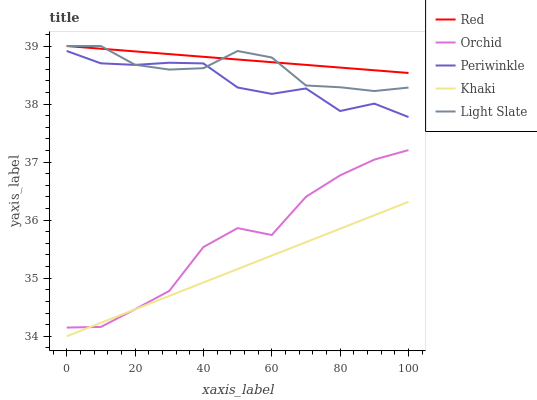Does Khaki have the minimum area under the curve?
Answer yes or no. Yes. Does Red have the maximum area under the curve?
Answer yes or no. Yes. Does Periwinkle have the minimum area under the curve?
Answer yes or no. No. Does Periwinkle have the maximum area under the curve?
Answer yes or no. No. Is Khaki the smoothest?
Answer yes or no. Yes. Is Orchid the roughest?
Answer yes or no. Yes. Is Periwinkle the smoothest?
Answer yes or no. No. Is Periwinkle the roughest?
Answer yes or no. No. Does Khaki have the lowest value?
Answer yes or no. Yes. Does Periwinkle have the lowest value?
Answer yes or no. No. Does Red have the highest value?
Answer yes or no. Yes. Does Periwinkle have the highest value?
Answer yes or no. No. Is Orchid less than Light Slate?
Answer yes or no. Yes. Is Light Slate greater than Khaki?
Answer yes or no. Yes. Does Red intersect Light Slate?
Answer yes or no. Yes. Is Red less than Light Slate?
Answer yes or no. No. Is Red greater than Light Slate?
Answer yes or no. No. Does Orchid intersect Light Slate?
Answer yes or no. No. 